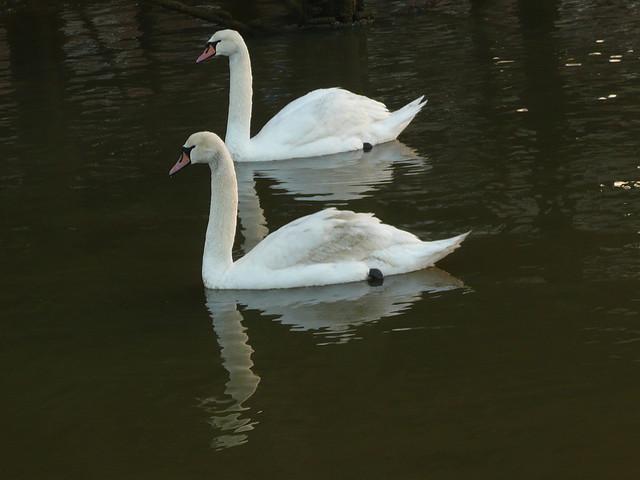How many animals are pictured?
Give a very brief answer. 2. How many vehicles are in the photo?
Give a very brief answer. 0. How many birds are in the photo?
Give a very brief answer. 2. How many sheep are there?
Give a very brief answer. 0. 